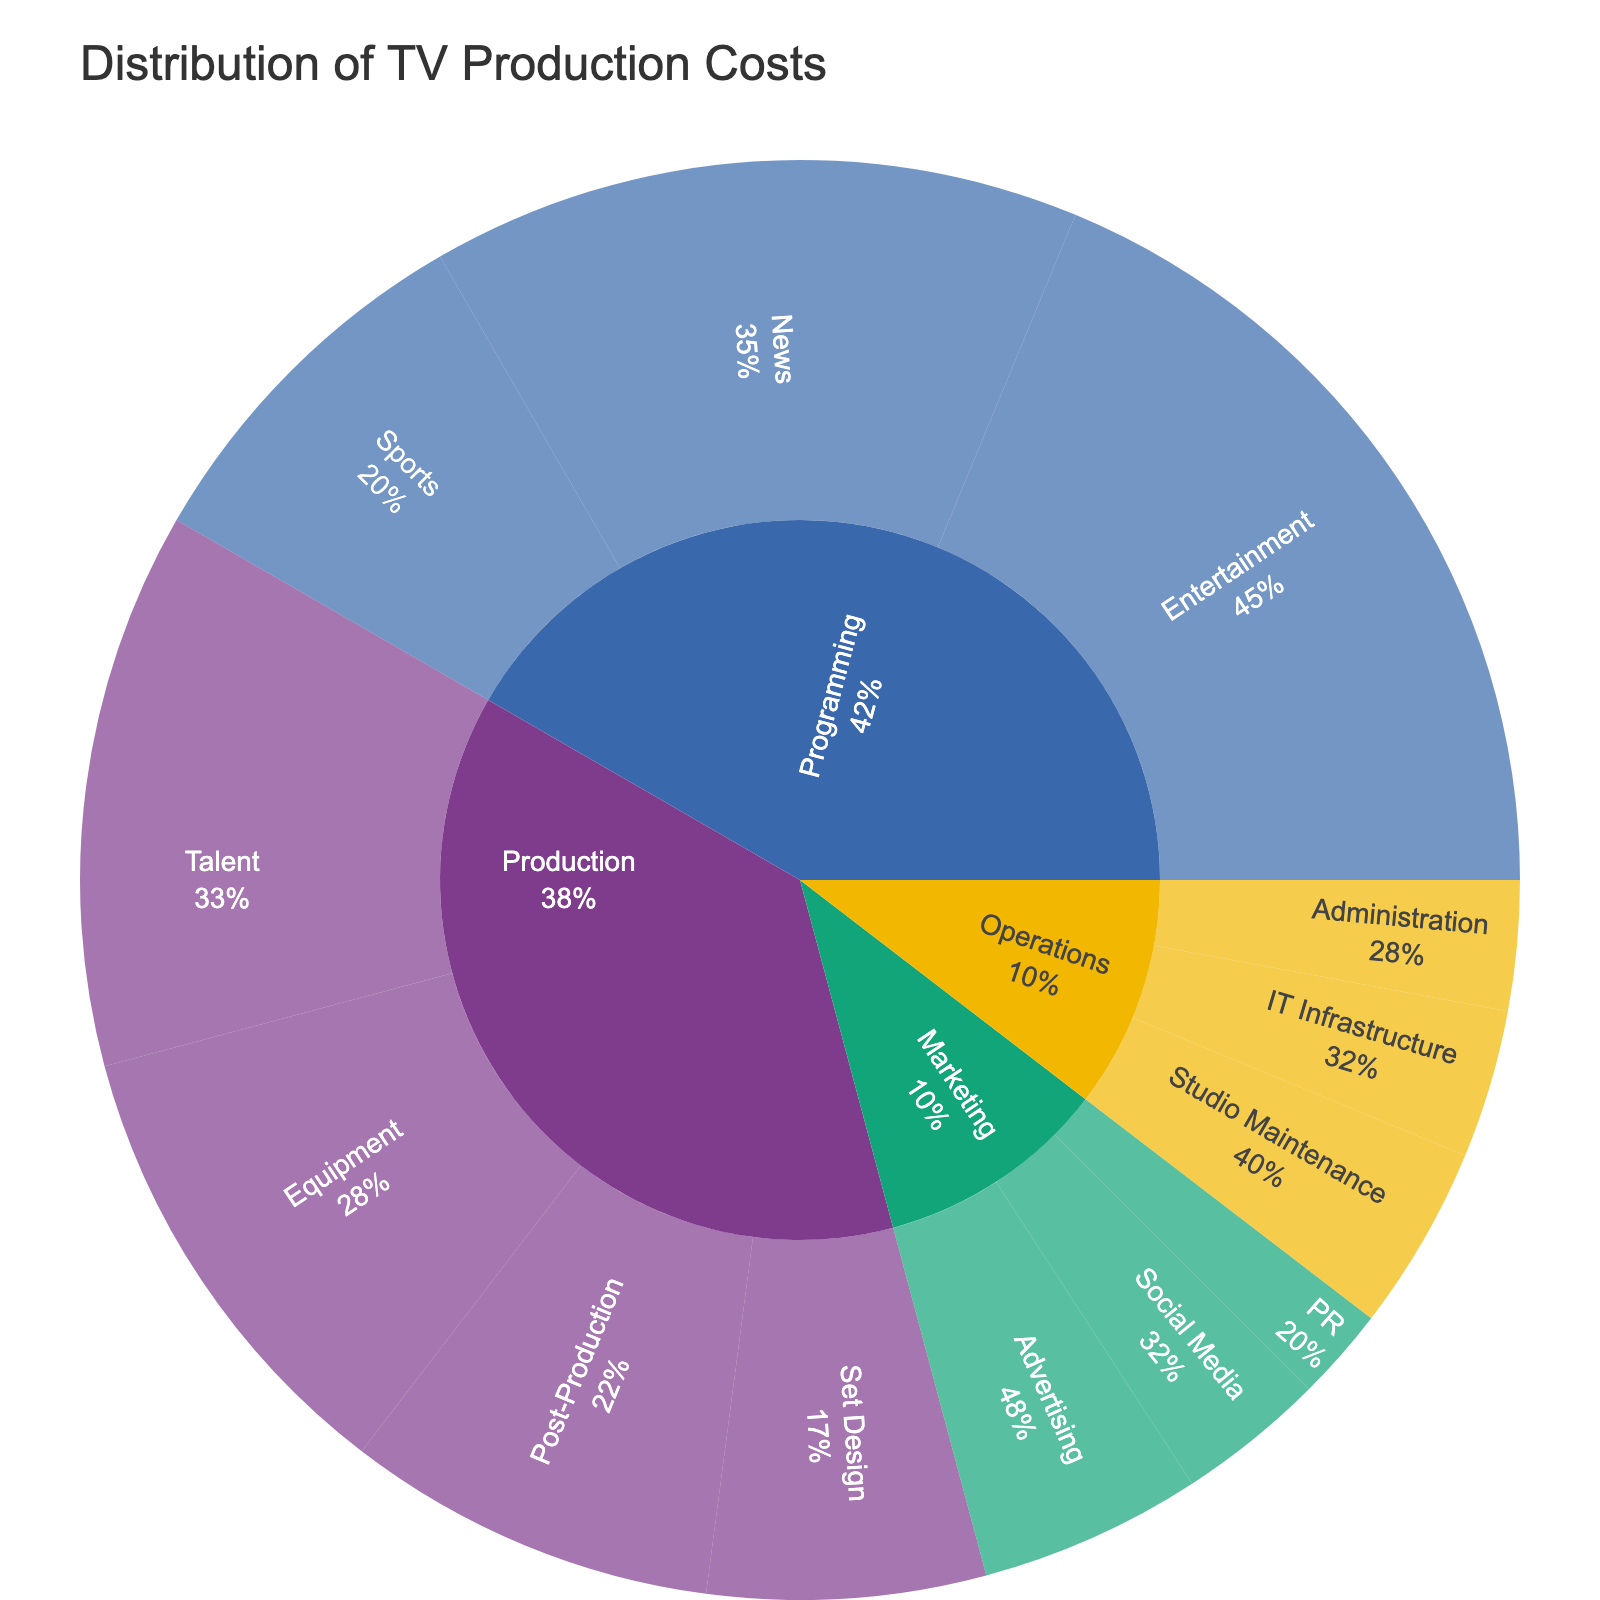What is the title of the sunburst plot? The title is displayed at the top of the plot. It is meant to describe what the plot is about.
Answer: Distribution of TV Production Costs Which subcategory has the highest cost within the Production category? Look at the segments within the Production category and find the one with the largest size.
Answer: Talent What is the combined cost of the News and Entertainment subcategories in the Programming category? Find the values for News and Entertainment under Programming and add them together: 35 + 45 = 80.
Answer: 80 Which department has the smallest total cost among Production, Programming, Marketing, and Operations? Compare the aggregated values of the segments under each department.
Answer: Operations How does the cost of Studio Maintenance compare to the cost of IT Infrastructure? Look at the segments for Studio Maintenance and IT Infrastructure under Operations and compare their values.
Answer: Studio Maintenance is higher Which category has the most diverse distribution of costs among its subcategories? Look at the evenness of sizes of segments within each category. The more even the sizes, the more diverse the distribution.
Answer: Production What is the percentage of cost attributed to Set Design within the Production category? Using the hover information or the segment size, compare the value of Set Design to the total value of the Production category: (Set Design / Total Production) * 100 = (15 / 90) * 100 = 16.7%.
Answer: 16.7% Is the cost for Sports higher than the total cost for all subcategories under Marketing? Compare the value for Sports with the sum of all values under Marketing: 20 vs (12 + 8 + 5 = 25).
Answer: No Which subcategory in Marketing has the lowest cost? Look for the smallest segment within the Marketing category.
Answer: PR What percentage of the total TV production cost does Post-Production represent? Calculate the total cost of all categories and then find the percentage that Post-Production represents: (Post-Production / Total) * 100 = (20 / 240) * 100 = 8.3%.
Answer: 8.3% 